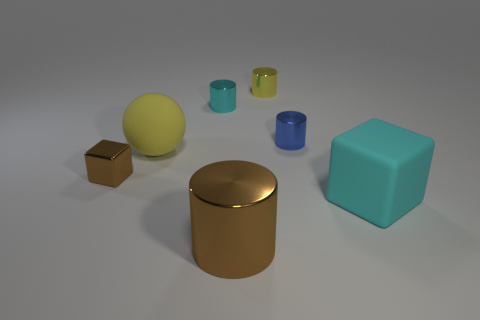What size is the metal object in front of the large cyan matte block?
Provide a succinct answer. Large. Is there a large brown thing made of the same material as the small blue cylinder?
Your answer should be compact. Yes. Does the tiny shiny cylinder that is left of the large brown thing have the same color as the big rubber block?
Your response must be concise. Yes. Are there the same number of small metal cubes that are behind the large yellow rubber sphere and tiny purple blocks?
Make the answer very short. Yes. Are there any large shiny cylinders of the same color as the big sphere?
Give a very brief answer. No. Do the cyan rubber cube and the metallic cube have the same size?
Make the answer very short. No. There is a brown cylinder that is in front of the large matte sphere that is in front of the tiny blue object; what is its size?
Offer a very short reply. Large. What is the size of the metallic object that is both on the right side of the ball and left of the large cylinder?
Provide a short and direct response. Small. How many cyan cylinders are the same size as the blue object?
Offer a terse response. 1. What number of matte objects are big yellow objects or blue things?
Keep it short and to the point. 1. 